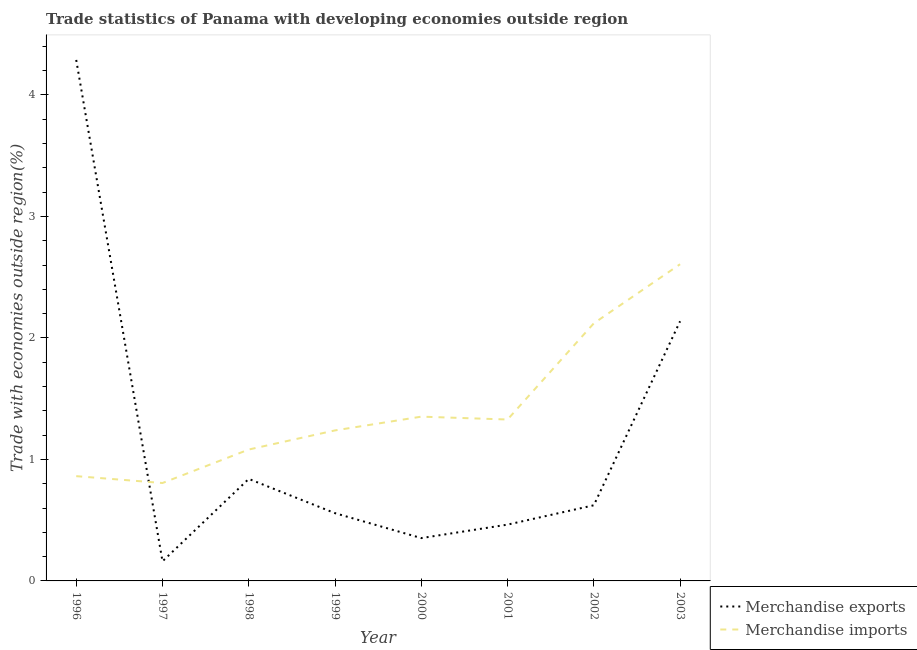Is the number of lines equal to the number of legend labels?
Your response must be concise. Yes. What is the merchandise imports in 2000?
Offer a terse response. 1.35. Across all years, what is the maximum merchandise imports?
Your response must be concise. 2.61. Across all years, what is the minimum merchandise imports?
Your response must be concise. 0.81. What is the total merchandise exports in the graph?
Give a very brief answer. 9.42. What is the difference between the merchandise exports in 1997 and that in 2001?
Offer a very short reply. -0.3. What is the difference between the merchandise imports in 2003 and the merchandise exports in 2002?
Offer a terse response. 1.98. What is the average merchandise imports per year?
Keep it short and to the point. 1.42. In the year 1999, what is the difference between the merchandise imports and merchandise exports?
Offer a terse response. 0.68. What is the ratio of the merchandise exports in 2001 to that in 2002?
Keep it short and to the point. 0.74. What is the difference between the highest and the second highest merchandise imports?
Your response must be concise. 0.49. What is the difference between the highest and the lowest merchandise imports?
Provide a short and direct response. 1.8. In how many years, is the merchandise exports greater than the average merchandise exports taken over all years?
Provide a short and direct response. 2. Does the graph contain any zero values?
Provide a succinct answer. No. Does the graph contain grids?
Provide a succinct answer. No. Where does the legend appear in the graph?
Offer a very short reply. Bottom right. How many legend labels are there?
Give a very brief answer. 2. How are the legend labels stacked?
Ensure brevity in your answer.  Vertical. What is the title of the graph?
Offer a terse response. Trade statistics of Panama with developing economies outside region. What is the label or title of the Y-axis?
Your response must be concise. Trade with economies outside region(%). What is the Trade with economies outside region(%) of Merchandise exports in 1996?
Your response must be concise. 4.29. What is the Trade with economies outside region(%) of Merchandise imports in 1996?
Give a very brief answer. 0.86. What is the Trade with economies outside region(%) of Merchandise exports in 1997?
Make the answer very short. 0.16. What is the Trade with economies outside region(%) of Merchandise imports in 1997?
Make the answer very short. 0.81. What is the Trade with economies outside region(%) of Merchandise exports in 1998?
Give a very brief answer. 0.84. What is the Trade with economies outside region(%) of Merchandise imports in 1998?
Offer a terse response. 1.08. What is the Trade with economies outside region(%) of Merchandise exports in 1999?
Your answer should be compact. 0.56. What is the Trade with economies outside region(%) of Merchandise imports in 1999?
Make the answer very short. 1.24. What is the Trade with economies outside region(%) in Merchandise exports in 2000?
Offer a very short reply. 0.35. What is the Trade with economies outside region(%) in Merchandise imports in 2000?
Your response must be concise. 1.35. What is the Trade with economies outside region(%) in Merchandise exports in 2001?
Provide a succinct answer. 0.46. What is the Trade with economies outside region(%) in Merchandise imports in 2001?
Ensure brevity in your answer.  1.33. What is the Trade with economies outside region(%) of Merchandise exports in 2002?
Your response must be concise. 0.62. What is the Trade with economies outside region(%) of Merchandise imports in 2002?
Ensure brevity in your answer.  2.12. What is the Trade with economies outside region(%) of Merchandise exports in 2003?
Your response must be concise. 2.14. What is the Trade with economies outside region(%) in Merchandise imports in 2003?
Give a very brief answer. 2.61. Across all years, what is the maximum Trade with economies outside region(%) of Merchandise exports?
Offer a very short reply. 4.29. Across all years, what is the maximum Trade with economies outside region(%) of Merchandise imports?
Provide a short and direct response. 2.61. Across all years, what is the minimum Trade with economies outside region(%) in Merchandise exports?
Your answer should be very brief. 0.16. Across all years, what is the minimum Trade with economies outside region(%) of Merchandise imports?
Your answer should be very brief. 0.81. What is the total Trade with economies outside region(%) in Merchandise exports in the graph?
Offer a very short reply. 9.42. What is the total Trade with economies outside region(%) in Merchandise imports in the graph?
Keep it short and to the point. 11.4. What is the difference between the Trade with economies outside region(%) of Merchandise exports in 1996 and that in 1997?
Keep it short and to the point. 4.13. What is the difference between the Trade with economies outside region(%) of Merchandise imports in 1996 and that in 1997?
Ensure brevity in your answer.  0.06. What is the difference between the Trade with economies outside region(%) of Merchandise exports in 1996 and that in 1998?
Ensure brevity in your answer.  3.45. What is the difference between the Trade with economies outside region(%) of Merchandise imports in 1996 and that in 1998?
Offer a very short reply. -0.22. What is the difference between the Trade with economies outside region(%) in Merchandise exports in 1996 and that in 1999?
Provide a succinct answer. 3.73. What is the difference between the Trade with economies outside region(%) in Merchandise imports in 1996 and that in 1999?
Your response must be concise. -0.38. What is the difference between the Trade with economies outside region(%) of Merchandise exports in 1996 and that in 2000?
Make the answer very short. 3.94. What is the difference between the Trade with economies outside region(%) of Merchandise imports in 1996 and that in 2000?
Provide a short and direct response. -0.49. What is the difference between the Trade with economies outside region(%) of Merchandise exports in 1996 and that in 2001?
Your answer should be compact. 3.82. What is the difference between the Trade with economies outside region(%) in Merchandise imports in 1996 and that in 2001?
Offer a terse response. -0.47. What is the difference between the Trade with economies outside region(%) in Merchandise exports in 1996 and that in 2002?
Give a very brief answer. 3.67. What is the difference between the Trade with economies outside region(%) of Merchandise imports in 1996 and that in 2002?
Your response must be concise. -1.26. What is the difference between the Trade with economies outside region(%) of Merchandise exports in 1996 and that in 2003?
Provide a short and direct response. 2.15. What is the difference between the Trade with economies outside region(%) of Merchandise imports in 1996 and that in 2003?
Make the answer very short. -1.74. What is the difference between the Trade with economies outside region(%) in Merchandise exports in 1997 and that in 1998?
Provide a succinct answer. -0.68. What is the difference between the Trade with economies outside region(%) in Merchandise imports in 1997 and that in 1998?
Make the answer very short. -0.28. What is the difference between the Trade with economies outside region(%) of Merchandise exports in 1997 and that in 1999?
Make the answer very short. -0.4. What is the difference between the Trade with economies outside region(%) in Merchandise imports in 1997 and that in 1999?
Offer a very short reply. -0.43. What is the difference between the Trade with economies outside region(%) of Merchandise exports in 1997 and that in 2000?
Keep it short and to the point. -0.19. What is the difference between the Trade with economies outside region(%) in Merchandise imports in 1997 and that in 2000?
Your answer should be compact. -0.55. What is the difference between the Trade with economies outside region(%) in Merchandise exports in 1997 and that in 2001?
Make the answer very short. -0.3. What is the difference between the Trade with economies outside region(%) of Merchandise imports in 1997 and that in 2001?
Your answer should be very brief. -0.52. What is the difference between the Trade with economies outside region(%) of Merchandise exports in 1997 and that in 2002?
Your answer should be compact. -0.46. What is the difference between the Trade with economies outside region(%) of Merchandise imports in 1997 and that in 2002?
Provide a succinct answer. -1.31. What is the difference between the Trade with economies outside region(%) of Merchandise exports in 1997 and that in 2003?
Your answer should be compact. -1.98. What is the difference between the Trade with economies outside region(%) in Merchandise imports in 1997 and that in 2003?
Keep it short and to the point. -1.8. What is the difference between the Trade with economies outside region(%) of Merchandise exports in 1998 and that in 1999?
Give a very brief answer. 0.28. What is the difference between the Trade with economies outside region(%) in Merchandise imports in 1998 and that in 1999?
Give a very brief answer. -0.16. What is the difference between the Trade with economies outside region(%) in Merchandise exports in 1998 and that in 2000?
Keep it short and to the point. 0.49. What is the difference between the Trade with economies outside region(%) of Merchandise imports in 1998 and that in 2000?
Your answer should be compact. -0.27. What is the difference between the Trade with economies outside region(%) of Merchandise exports in 1998 and that in 2001?
Your answer should be compact. 0.38. What is the difference between the Trade with economies outside region(%) of Merchandise imports in 1998 and that in 2001?
Provide a short and direct response. -0.25. What is the difference between the Trade with economies outside region(%) of Merchandise exports in 1998 and that in 2002?
Your response must be concise. 0.22. What is the difference between the Trade with economies outside region(%) of Merchandise imports in 1998 and that in 2002?
Provide a short and direct response. -1.04. What is the difference between the Trade with economies outside region(%) in Merchandise exports in 1998 and that in 2003?
Keep it short and to the point. -1.3. What is the difference between the Trade with economies outside region(%) of Merchandise imports in 1998 and that in 2003?
Offer a very short reply. -1.52. What is the difference between the Trade with economies outside region(%) of Merchandise exports in 1999 and that in 2000?
Keep it short and to the point. 0.2. What is the difference between the Trade with economies outside region(%) of Merchandise imports in 1999 and that in 2000?
Make the answer very short. -0.11. What is the difference between the Trade with economies outside region(%) in Merchandise exports in 1999 and that in 2001?
Offer a terse response. 0.09. What is the difference between the Trade with economies outside region(%) in Merchandise imports in 1999 and that in 2001?
Your response must be concise. -0.09. What is the difference between the Trade with economies outside region(%) in Merchandise exports in 1999 and that in 2002?
Provide a succinct answer. -0.07. What is the difference between the Trade with economies outside region(%) in Merchandise imports in 1999 and that in 2002?
Give a very brief answer. -0.88. What is the difference between the Trade with economies outside region(%) in Merchandise exports in 1999 and that in 2003?
Provide a short and direct response. -1.58. What is the difference between the Trade with economies outside region(%) of Merchandise imports in 1999 and that in 2003?
Give a very brief answer. -1.37. What is the difference between the Trade with economies outside region(%) of Merchandise exports in 2000 and that in 2001?
Your answer should be compact. -0.11. What is the difference between the Trade with economies outside region(%) in Merchandise imports in 2000 and that in 2001?
Offer a very short reply. 0.02. What is the difference between the Trade with economies outside region(%) of Merchandise exports in 2000 and that in 2002?
Offer a very short reply. -0.27. What is the difference between the Trade with economies outside region(%) in Merchandise imports in 2000 and that in 2002?
Provide a short and direct response. -0.77. What is the difference between the Trade with economies outside region(%) of Merchandise exports in 2000 and that in 2003?
Offer a terse response. -1.78. What is the difference between the Trade with economies outside region(%) in Merchandise imports in 2000 and that in 2003?
Keep it short and to the point. -1.25. What is the difference between the Trade with economies outside region(%) in Merchandise exports in 2001 and that in 2002?
Keep it short and to the point. -0.16. What is the difference between the Trade with economies outside region(%) in Merchandise imports in 2001 and that in 2002?
Provide a short and direct response. -0.79. What is the difference between the Trade with economies outside region(%) in Merchandise exports in 2001 and that in 2003?
Your answer should be very brief. -1.67. What is the difference between the Trade with economies outside region(%) in Merchandise imports in 2001 and that in 2003?
Your response must be concise. -1.28. What is the difference between the Trade with economies outside region(%) of Merchandise exports in 2002 and that in 2003?
Offer a very short reply. -1.51. What is the difference between the Trade with economies outside region(%) in Merchandise imports in 2002 and that in 2003?
Make the answer very short. -0.49. What is the difference between the Trade with economies outside region(%) of Merchandise exports in 1996 and the Trade with economies outside region(%) of Merchandise imports in 1997?
Your answer should be very brief. 3.48. What is the difference between the Trade with economies outside region(%) in Merchandise exports in 1996 and the Trade with economies outside region(%) in Merchandise imports in 1998?
Your answer should be compact. 3.21. What is the difference between the Trade with economies outside region(%) of Merchandise exports in 1996 and the Trade with economies outside region(%) of Merchandise imports in 1999?
Provide a short and direct response. 3.05. What is the difference between the Trade with economies outside region(%) of Merchandise exports in 1996 and the Trade with economies outside region(%) of Merchandise imports in 2000?
Your response must be concise. 2.94. What is the difference between the Trade with economies outside region(%) in Merchandise exports in 1996 and the Trade with economies outside region(%) in Merchandise imports in 2001?
Your answer should be very brief. 2.96. What is the difference between the Trade with economies outside region(%) of Merchandise exports in 1996 and the Trade with economies outside region(%) of Merchandise imports in 2002?
Offer a very short reply. 2.17. What is the difference between the Trade with economies outside region(%) in Merchandise exports in 1996 and the Trade with economies outside region(%) in Merchandise imports in 2003?
Your response must be concise. 1.68. What is the difference between the Trade with economies outside region(%) of Merchandise exports in 1997 and the Trade with economies outside region(%) of Merchandise imports in 1998?
Offer a terse response. -0.92. What is the difference between the Trade with economies outside region(%) in Merchandise exports in 1997 and the Trade with economies outside region(%) in Merchandise imports in 1999?
Ensure brevity in your answer.  -1.08. What is the difference between the Trade with economies outside region(%) in Merchandise exports in 1997 and the Trade with economies outside region(%) in Merchandise imports in 2000?
Give a very brief answer. -1.19. What is the difference between the Trade with economies outside region(%) in Merchandise exports in 1997 and the Trade with economies outside region(%) in Merchandise imports in 2001?
Your answer should be compact. -1.17. What is the difference between the Trade with economies outside region(%) of Merchandise exports in 1997 and the Trade with economies outside region(%) of Merchandise imports in 2002?
Provide a short and direct response. -1.96. What is the difference between the Trade with economies outside region(%) in Merchandise exports in 1997 and the Trade with economies outside region(%) in Merchandise imports in 2003?
Offer a very short reply. -2.44. What is the difference between the Trade with economies outside region(%) of Merchandise exports in 1998 and the Trade with economies outside region(%) of Merchandise imports in 1999?
Offer a very short reply. -0.4. What is the difference between the Trade with economies outside region(%) in Merchandise exports in 1998 and the Trade with economies outside region(%) in Merchandise imports in 2000?
Offer a terse response. -0.51. What is the difference between the Trade with economies outside region(%) in Merchandise exports in 1998 and the Trade with economies outside region(%) in Merchandise imports in 2001?
Give a very brief answer. -0.49. What is the difference between the Trade with economies outside region(%) of Merchandise exports in 1998 and the Trade with economies outside region(%) of Merchandise imports in 2002?
Ensure brevity in your answer.  -1.28. What is the difference between the Trade with economies outside region(%) in Merchandise exports in 1998 and the Trade with economies outside region(%) in Merchandise imports in 2003?
Ensure brevity in your answer.  -1.77. What is the difference between the Trade with economies outside region(%) of Merchandise exports in 1999 and the Trade with economies outside region(%) of Merchandise imports in 2000?
Give a very brief answer. -0.79. What is the difference between the Trade with economies outside region(%) of Merchandise exports in 1999 and the Trade with economies outside region(%) of Merchandise imports in 2001?
Give a very brief answer. -0.77. What is the difference between the Trade with economies outside region(%) in Merchandise exports in 1999 and the Trade with economies outside region(%) in Merchandise imports in 2002?
Make the answer very short. -1.56. What is the difference between the Trade with economies outside region(%) in Merchandise exports in 1999 and the Trade with economies outside region(%) in Merchandise imports in 2003?
Provide a succinct answer. -2.05. What is the difference between the Trade with economies outside region(%) of Merchandise exports in 2000 and the Trade with economies outside region(%) of Merchandise imports in 2001?
Keep it short and to the point. -0.98. What is the difference between the Trade with economies outside region(%) in Merchandise exports in 2000 and the Trade with economies outside region(%) in Merchandise imports in 2002?
Keep it short and to the point. -1.77. What is the difference between the Trade with economies outside region(%) in Merchandise exports in 2000 and the Trade with economies outside region(%) in Merchandise imports in 2003?
Offer a terse response. -2.25. What is the difference between the Trade with economies outside region(%) of Merchandise exports in 2001 and the Trade with economies outside region(%) of Merchandise imports in 2002?
Your answer should be compact. -1.66. What is the difference between the Trade with economies outside region(%) in Merchandise exports in 2001 and the Trade with economies outside region(%) in Merchandise imports in 2003?
Offer a very short reply. -2.14. What is the difference between the Trade with economies outside region(%) of Merchandise exports in 2002 and the Trade with economies outside region(%) of Merchandise imports in 2003?
Provide a succinct answer. -1.98. What is the average Trade with economies outside region(%) in Merchandise exports per year?
Provide a short and direct response. 1.18. What is the average Trade with economies outside region(%) of Merchandise imports per year?
Ensure brevity in your answer.  1.42. In the year 1996, what is the difference between the Trade with economies outside region(%) of Merchandise exports and Trade with economies outside region(%) of Merchandise imports?
Offer a terse response. 3.43. In the year 1997, what is the difference between the Trade with economies outside region(%) of Merchandise exports and Trade with economies outside region(%) of Merchandise imports?
Ensure brevity in your answer.  -0.64. In the year 1998, what is the difference between the Trade with economies outside region(%) in Merchandise exports and Trade with economies outside region(%) in Merchandise imports?
Provide a succinct answer. -0.24. In the year 1999, what is the difference between the Trade with economies outside region(%) in Merchandise exports and Trade with economies outside region(%) in Merchandise imports?
Offer a very short reply. -0.68. In the year 2000, what is the difference between the Trade with economies outside region(%) of Merchandise exports and Trade with economies outside region(%) of Merchandise imports?
Offer a terse response. -1. In the year 2001, what is the difference between the Trade with economies outside region(%) of Merchandise exports and Trade with economies outside region(%) of Merchandise imports?
Your answer should be very brief. -0.86. In the year 2002, what is the difference between the Trade with economies outside region(%) in Merchandise exports and Trade with economies outside region(%) in Merchandise imports?
Ensure brevity in your answer.  -1.5. In the year 2003, what is the difference between the Trade with economies outside region(%) of Merchandise exports and Trade with economies outside region(%) of Merchandise imports?
Keep it short and to the point. -0.47. What is the ratio of the Trade with economies outside region(%) of Merchandise exports in 1996 to that in 1997?
Give a very brief answer. 26.56. What is the ratio of the Trade with economies outside region(%) of Merchandise imports in 1996 to that in 1997?
Your answer should be very brief. 1.07. What is the ratio of the Trade with economies outside region(%) in Merchandise exports in 1996 to that in 1998?
Your answer should be very brief. 5.11. What is the ratio of the Trade with economies outside region(%) of Merchandise imports in 1996 to that in 1998?
Provide a succinct answer. 0.8. What is the ratio of the Trade with economies outside region(%) in Merchandise exports in 1996 to that in 1999?
Your answer should be compact. 7.69. What is the ratio of the Trade with economies outside region(%) in Merchandise imports in 1996 to that in 1999?
Provide a succinct answer. 0.7. What is the ratio of the Trade with economies outside region(%) in Merchandise exports in 1996 to that in 2000?
Your answer should be compact. 12.16. What is the ratio of the Trade with economies outside region(%) of Merchandise imports in 1996 to that in 2000?
Your answer should be compact. 0.64. What is the ratio of the Trade with economies outside region(%) of Merchandise exports in 1996 to that in 2001?
Your answer should be very brief. 9.25. What is the ratio of the Trade with economies outside region(%) of Merchandise imports in 1996 to that in 2001?
Keep it short and to the point. 0.65. What is the ratio of the Trade with economies outside region(%) in Merchandise exports in 1996 to that in 2002?
Offer a terse response. 6.89. What is the ratio of the Trade with economies outside region(%) of Merchandise imports in 1996 to that in 2002?
Your answer should be very brief. 0.41. What is the ratio of the Trade with economies outside region(%) in Merchandise exports in 1996 to that in 2003?
Offer a terse response. 2.01. What is the ratio of the Trade with economies outside region(%) of Merchandise imports in 1996 to that in 2003?
Offer a very short reply. 0.33. What is the ratio of the Trade with economies outside region(%) of Merchandise exports in 1997 to that in 1998?
Your answer should be compact. 0.19. What is the ratio of the Trade with economies outside region(%) in Merchandise imports in 1997 to that in 1998?
Make the answer very short. 0.75. What is the ratio of the Trade with economies outside region(%) of Merchandise exports in 1997 to that in 1999?
Ensure brevity in your answer.  0.29. What is the ratio of the Trade with economies outside region(%) in Merchandise imports in 1997 to that in 1999?
Offer a terse response. 0.65. What is the ratio of the Trade with economies outside region(%) of Merchandise exports in 1997 to that in 2000?
Offer a very short reply. 0.46. What is the ratio of the Trade with economies outside region(%) in Merchandise imports in 1997 to that in 2000?
Ensure brevity in your answer.  0.6. What is the ratio of the Trade with economies outside region(%) in Merchandise exports in 1997 to that in 2001?
Make the answer very short. 0.35. What is the ratio of the Trade with economies outside region(%) in Merchandise imports in 1997 to that in 2001?
Offer a terse response. 0.61. What is the ratio of the Trade with economies outside region(%) of Merchandise exports in 1997 to that in 2002?
Your answer should be very brief. 0.26. What is the ratio of the Trade with economies outside region(%) in Merchandise imports in 1997 to that in 2002?
Provide a short and direct response. 0.38. What is the ratio of the Trade with economies outside region(%) in Merchandise exports in 1997 to that in 2003?
Make the answer very short. 0.08. What is the ratio of the Trade with economies outside region(%) in Merchandise imports in 1997 to that in 2003?
Provide a short and direct response. 0.31. What is the ratio of the Trade with economies outside region(%) in Merchandise exports in 1998 to that in 1999?
Your response must be concise. 1.51. What is the ratio of the Trade with economies outside region(%) in Merchandise imports in 1998 to that in 1999?
Make the answer very short. 0.87. What is the ratio of the Trade with economies outside region(%) in Merchandise exports in 1998 to that in 2000?
Make the answer very short. 2.38. What is the ratio of the Trade with economies outside region(%) in Merchandise imports in 1998 to that in 2000?
Give a very brief answer. 0.8. What is the ratio of the Trade with economies outside region(%) of Merchandise exports in 1998 to that in 2001?
Give a very brief answer. 1.81. What is the ratio of the Trade with economies outside region(%) in Merchandise imports in 1998 to that in 2001?
Your response must be concise. 0.81. What is the ratio of the Trade with economies outside region(%) in Merchandise exports in 1998 to that in 2002?
Your response must be concise. 1.35. What is the ratio of the Trade with economies outside region(%) in Merchandise imports in 1998 to that in 2002?
Ensure brevity in your answer.  0.51. What is the ratio of the Trade with economies outside region(%) in Merchandise exports in 1998 to that in 2003?
Your answer should be compact. 0.39. What is the ratio of the Trade with economies outside region(%) of Merchandise imports in 1998 to that in 2003?
Your answer should be compact. 0.41. What is the ratio of the Trade with economies outside region(%) of Merchandise exports in 1999 to that in 2000?
Give a very brief answer. 1.58. What is the ratio of the Trade with economies outside region(%) in Merchandise imports in 1999 to that in 2000?
Your answer should be very brief. 0.92. What is the ratio of the Trade with economies outside region(%) in Merchandise exports in 1999 to that in 2001?
Keep it short and to the point. 1.2. What is the ratio of the Trade with economies outside region(%) of Merchandise imports in 1999 to that in 2001?
Offer a very short reply. 0.93. What is the ratio of the Trade with economies outside region(%) of Merchandise exports in 1999 to that in 2002?
Provide a short and direct response. 0.9. What is the ratio of the Trade with economies outside region(%) in Merchandise imports in 1999 to that in 2002?
Provide a succinct answer. 0.58. What is the ratio of the Trade with economies outside region(%) in Merchandise exports in 1999 to that in 2003?
Keep it short and to the point. 0.26. What is the ratio of the Trade with economies outside region(%) of Merchandise imports in 1999 to that in 2003?
Your answer should be compact. 0.48. What is the ratio of the Trade with economies outside region(%) in Merchandise exports in 2000 to that in 2001?
Offer a terse response. 0.76. What is the ratio of the Trade with economies outside region(%) in Merchandise imports in 2000 to that in 2001?
Give a very brief answer. 1.02. What is the ratio of the Trade with economies outside region(%) in Merchandise exports in 2000 to that in 2002?
Give a very brief answer. 0.57. What is the ratio of the Trade with economies outside region(%) of Merchandise imports in 2000 to that in 2002?
Give a very brief answer. 0.64. What is the ratio of the Trade with economies outside region(%) of Merchandise exports in 2000 to that in 2003?
Provide a short and direct response. 0.16. What is the ratio of the Trade with economies outside region(%) in Merchandise imports in 2000 to that in 2003?
Offer a terse response. 0.52. What is the ratio of the Trade with economies outside region(%) in Merchandise exports in 2001 to that in 2002?
Keep it short and to the point. 0.74. What is the ratio of the Trade with economies outside region(%) of Merchandise imports in 2001 to that in 2002?
Ensure brevity in your answer.  0.63. What is the ratio of the Trade with economies outside region(%) in Merchandise exports in 2001 to that in 2003?
Your answer should be very brief. 0.22. What is the ratio of the Trade with economies outside region(%) of Merchandise imports in 2001 to that in 2003?
Your answer should be very brief. 0.51. What is the ratio of the Trade with economies outside region(%) of Merchandise exports in 2002 to that in 2003?
Offer a very short reply. 0.29. What is the ratio of the Trade with economies outside region(%) in Merchandise imports in 2002 to that in 2003?
Make the answer very short. 0.81. What is the difference between the highest and the second highest Trade with economies outside region(%) of Merchandise exports?
Make the answer very short. 2.15. What is the difference between the highest and the second highest Trade with economies outside region(%) of Merchandise imports?
Your answer should be compact. 0.49. What is the difference between the highest and the lowest Trade with economies outside region(%) of Merchandise exports?
Offer a very short reply. 4.13. What is the difference between the highest and the lowest Trade with economies outside region(%) in Merchandise imports?
Provide a succinct answer. 1.8. 